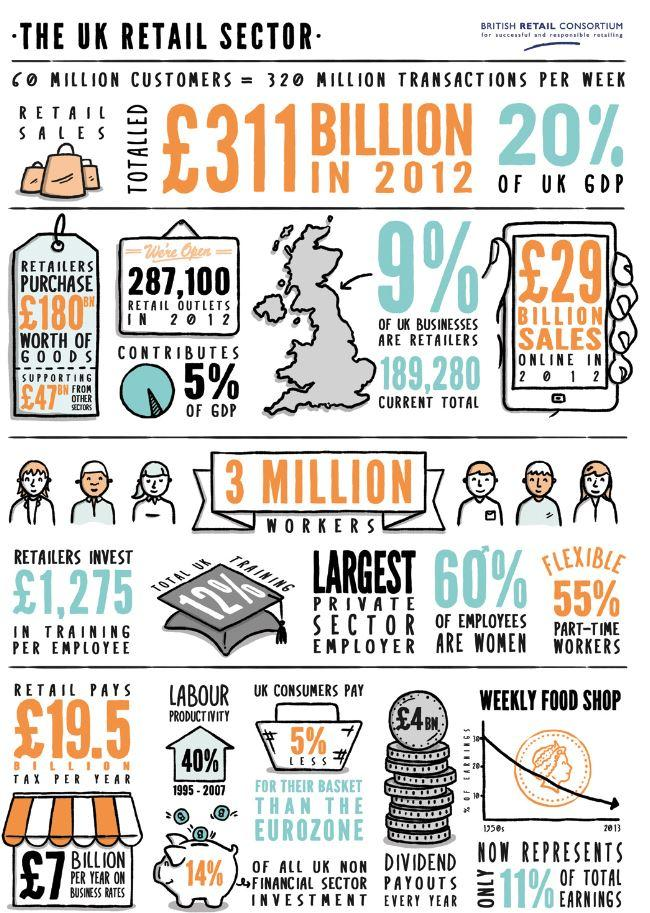Highlight a few significant elements in this photo. During the period of 1995-2007, the UK achieved 40% of its labour productivity. In 2012, retail sales made up approximately 20% of the UK's Gross Domestic Product (GDP). In 2012, 40% of employees working in the retail sector in the United Kingdom were men. In 2012, there were approximately 3 million people employed in the retail sector in the United Kingdom. In the year 2012, the retail sector in the UK achieved a staggering £29 billion in sales. 